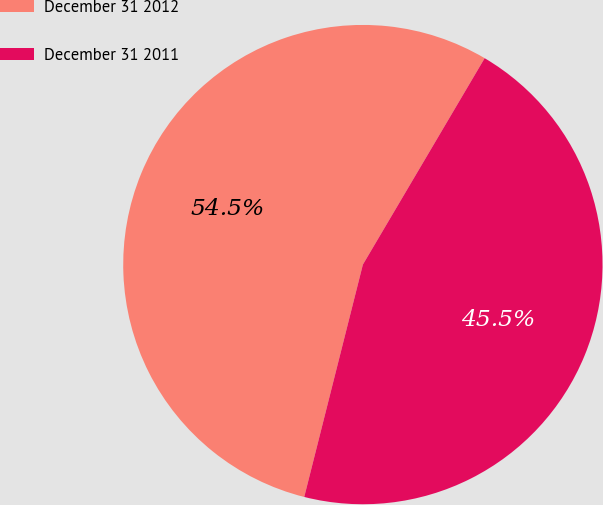<chart> <loc_0><loc_0><loc_500><loc_500><pie_chart><fcel>December 31 2012<fcel>December 31 2011<nl><fcel>54.55%<fcel>45.45%<nl></chart> 